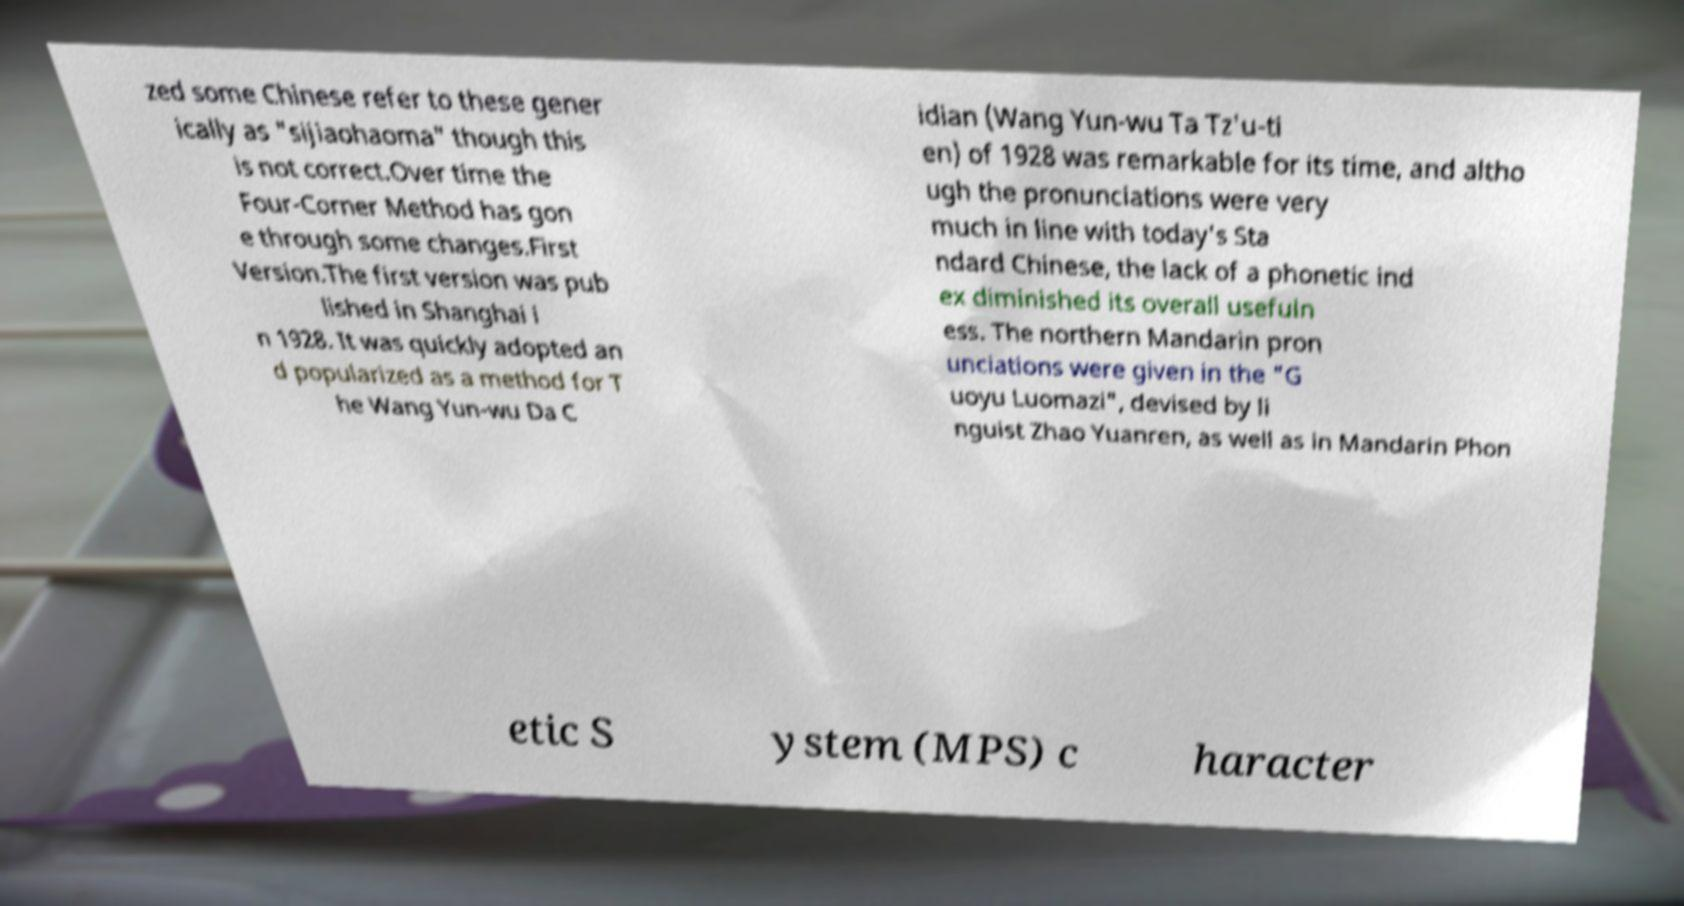Please identify and transcribe the text found in this image. zed some Chinese refer to these gener ically as "sijiaohaoma" though this is not correct.Over time the Four-Corner Method has gon e through some changes.First Version.The first version was pub lished in Shanghai i n 1928. It was quickly adopted an d popularized as a method for T he Wang Yun-wu Da C idian (Wang Yun-wu Ta Tz'u-ti en) of 1928 was remarkable for its time, and altho ugh the pronunciations were very much in line with today's Sta ndard Chinese, the lack of a phonetic ind ex diminished its overall usefuln ess. The northern Mandarin pron unciations were given in the "G uoyu Luomazi", devised by li nguist Zhao Yuanren, as well as in Mandarin Phon etic S ystem (MPS) c haracter 